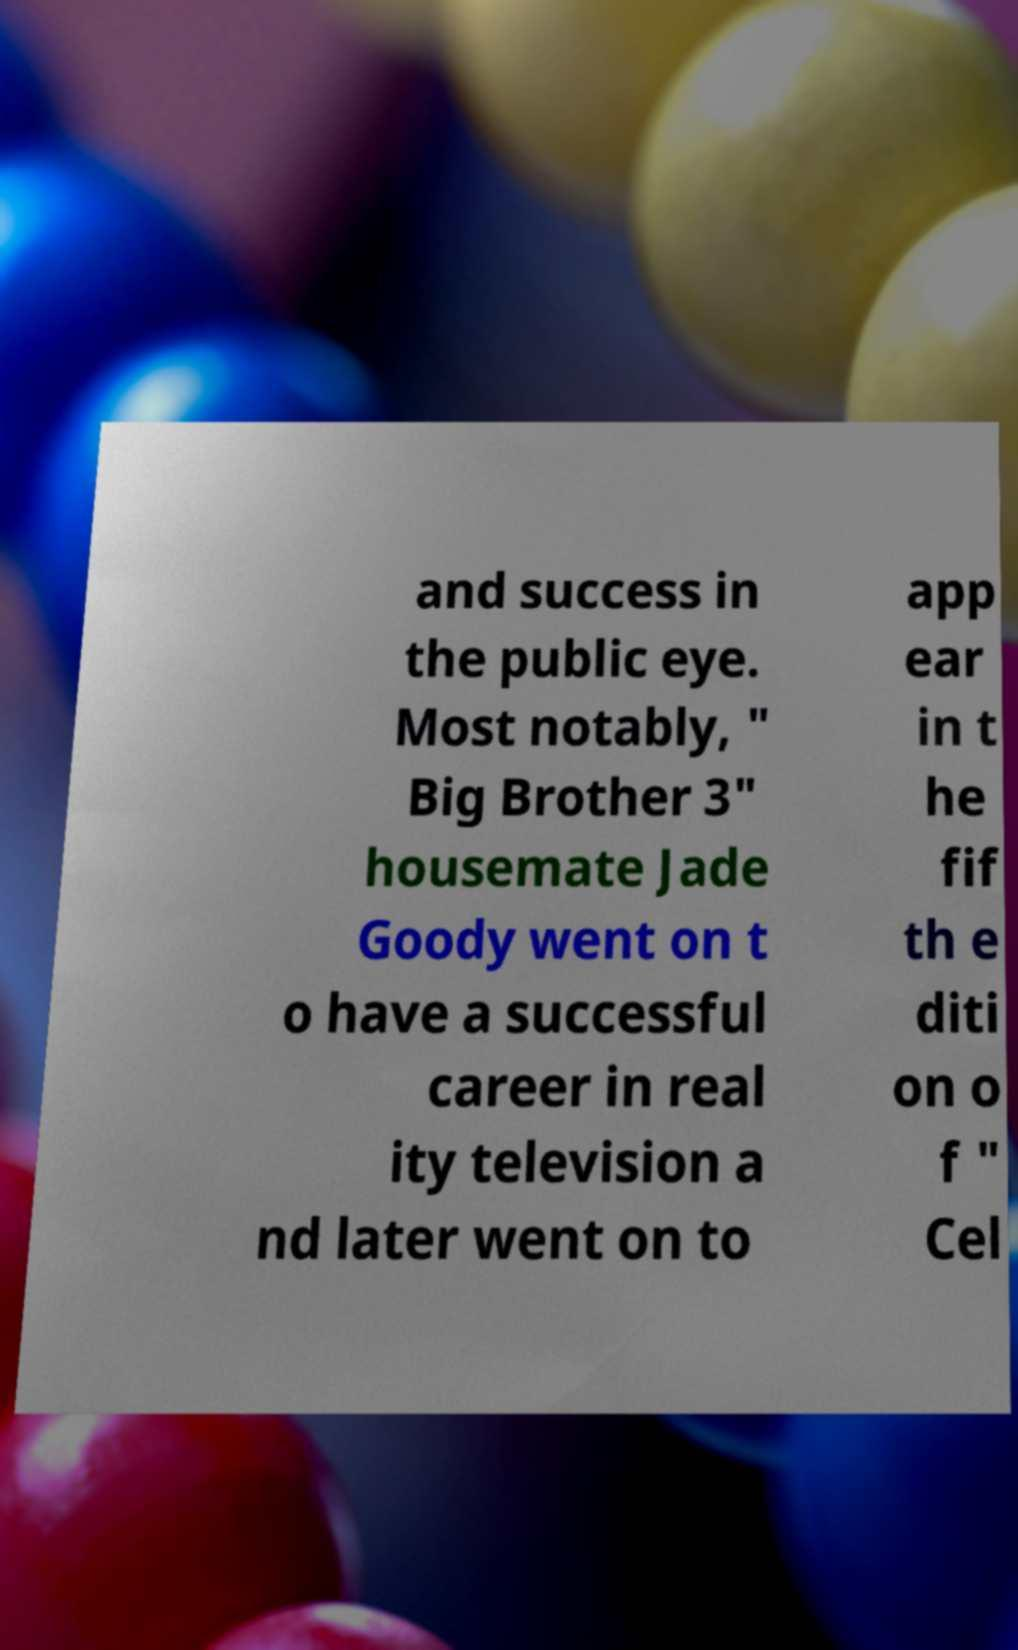For documentation purposes, I need the text within this image transcribed. Could you provide that? and success in the public eye. Most notably, " Big Brother 3" housemate Jade Goody went on t o have a successful career in real ity television a nd later went on to app ear in t he fif th e diti on o f " Cel 